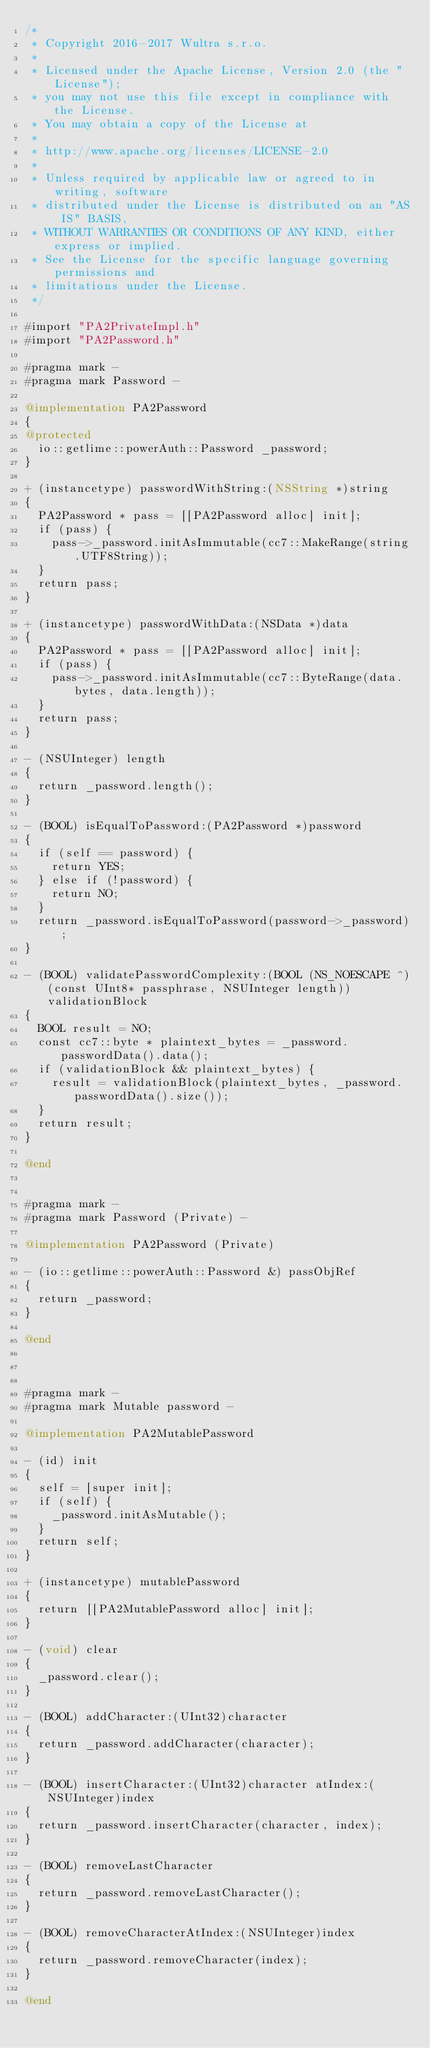<code> <loc_0><loc_0><loc_500><loc_500><_ObjectiveC_>/*
 * Copyright 2016-2017 Wultra s.r.o.
 *
 * Licensed under the Apache License, Version 2.0 (the "License");
 * you may not use this file except in compliance with the License.
 * You may obtain a copy of the License at
 *
 * http://www.apache.org/licenses/LICENSE-2.0
 *
 * Unless required by applicable law or agreed to in writing, software
 * distributed under the License is distributed on an "AS IS" BASIS,
 * WITHOUT WARRANTIES OR CONDITIONS OF ANY KIND, either express or implied.
 * See the License for the specific language governing permissions and
 * limitations under the License.
 */

#import "PA2PrivateImpl.h"
#import "PA2Password.h"

#pragma mark -
#pragma mark Password -

@implementation PA2Password
{
@protected
	io::getlime::powerAuth::Password _password;
}

+ (instancetype) passwordWithString:(NSString *)string
{
	PA2Password * pass = [[PA2Password alloc] init];
	if (pass) {
		pass->_password.initAsImmutable(cc7::MakeRange(string.UTF8String));
	}
	return pass;
}

+ (instancetype) passwordWithData:(NSData *)data
{
	PA2Password * pass = [[PA2Password alloc] init];
	if (pass) {
		pass->_password.initAsImmutable(cc7::ByteRange(data.bytes, data.length));
	}
	return pass;
}

- (NSUInteger) length
{
	return _password.length();
}

- (BOOL) isEqualToPassword:(PA2Password *)password
{
	if (self == password) {
		return YES;
	} else if (!password) {
		return NO;
	}
	return _password.isEqualToPassword(password->_password);
}

- (BOOL) validatePasswordComplexity:(BOOL (NS_NOESCAPE ^)(const UInt8* passphrase, NSUInteger length))validationBlock
{
	BOOL result = NO;
	const cc7::byte * plaintext_bytes = _password.passwordData().data();
	if (validationBlock && plaintext_bytes) {
		result = validationBlock(plaintext_bytes, _password.passwordData().size());
	}
	return result;
}

@end


#pragma mark -
#pragma mark Password (Private) -

@implementation PA2Password (Private)

- (io::getlime::powerAuth::Password &) passObjRef
{
	return _password;
}

@end



#pragma mark -
#pragma mark Mutable password -

@implementation PA2MutablePassword

- (id) init
{
	self = [super init];
	if (self) {
		_password.initAsMutable();
	}
	return self;
}

+ (instancetype) mutablePassword
{
	return [[PA2MutablePassword alloc] init];
}

- (void) clear
{
	_password.clear();
}

- (BOOL) addCharacter:(UInt32)character
{
	return _password.addCharacter(character);
}

- (BOOL) insertCharacter:(UInt32)character atIndex:(NSUInteger)index
{
	return _password.insertCharacter(character, index);
}

- (BOOL) removeLastCharacter
{
	return _password.removeLastCharacter();
}

- (BOOL) removeCharacterAtIndex:(NSUInteger)index
{
	return _password.removeCharacter(index);
}

@end
</code> 